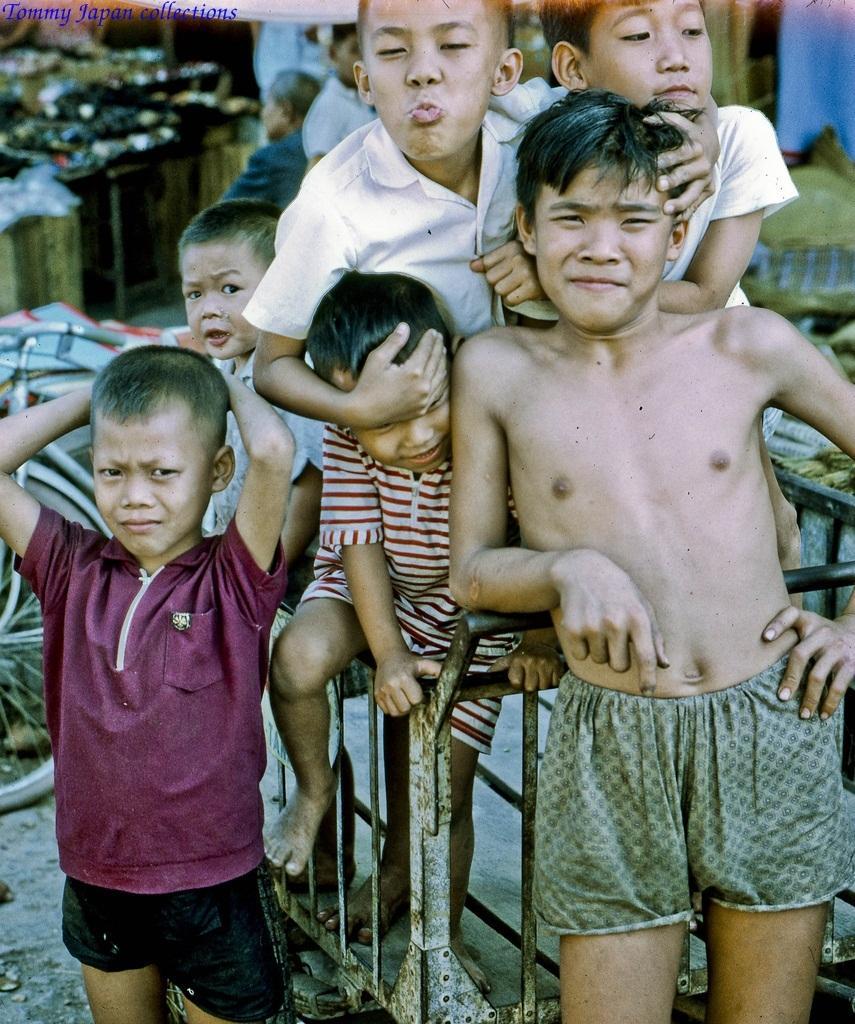Please provide a concise description of this image. In this image I can see few people. And these people are wearing the different color dresses. To the left I can see the bicycle. In the back I can see few more people and some objects and it is blurry. 